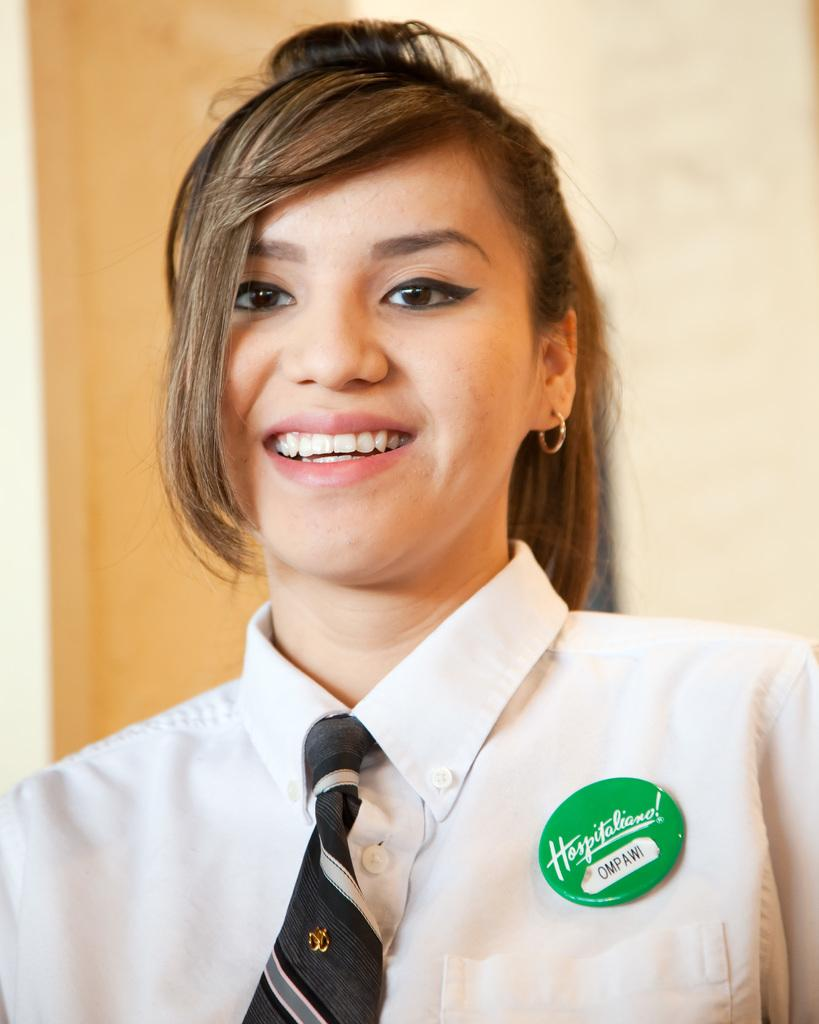<image>
Present a compact description of the photo's key features. A woman wearing a name tag that says Ompawi. 